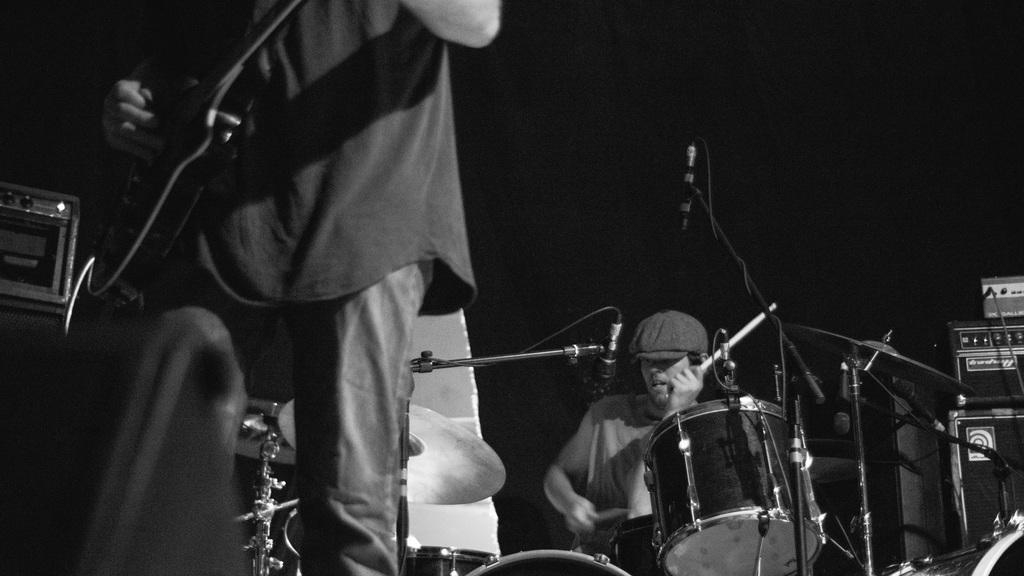Could you give a brief overview of what you see in this image? This is dark picture where we can see a person holding a mike and playing it and also some instruments and also a person who is standing and holding a instrument. 